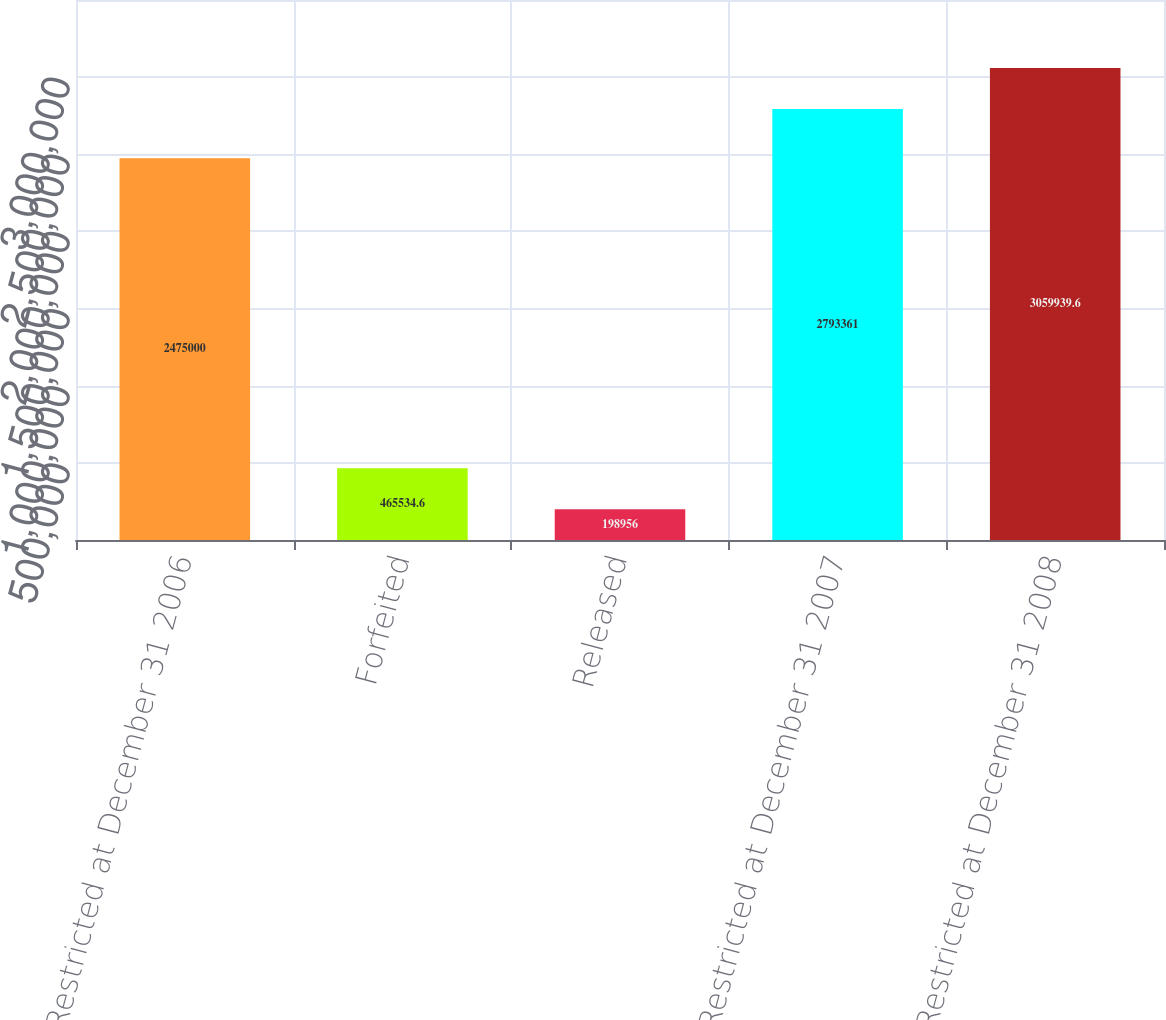Convert chart to OTSL. <chart><loc_0><loc_0><loc_500><loc_500><bar_chart><fcel>Restricted at December 31 2006<fcel>Forfeited<fcel>Released<fcel>Restricted at December 31 2007<fcel>Restricted at December 31 2008<nl><fcel>2.475e+06<fcel>465535<fcel>198956<fcel>2.79336e+06<fcel>3.05994e+06<nl></chart> 